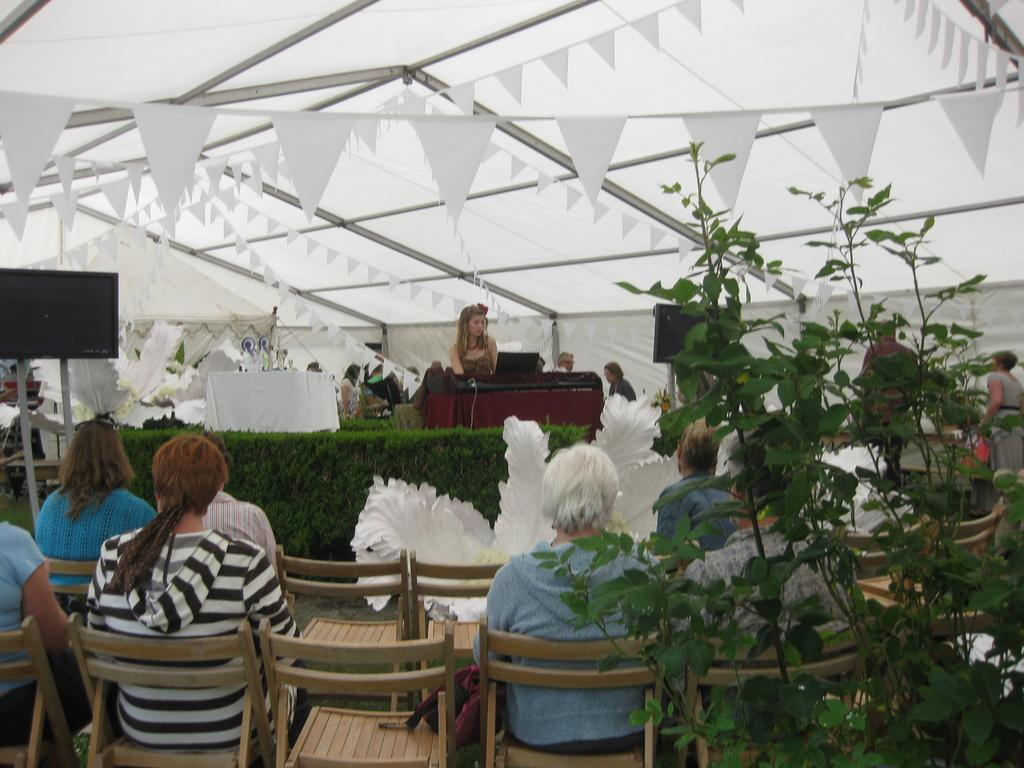What are the people in the image doing? There is a group of people seated on chairs in the image. What electronic device can be seen in the image? There is a television in the image. What type of vegetation is present in the image? There are plants in the image. Can you describe the position of the woman in the image? There is a woman seated on a dais in the image. What type of ear is visible on the television in the image? There is no ear visible on the television in the image; it is an electronic device for displaying visual content. 